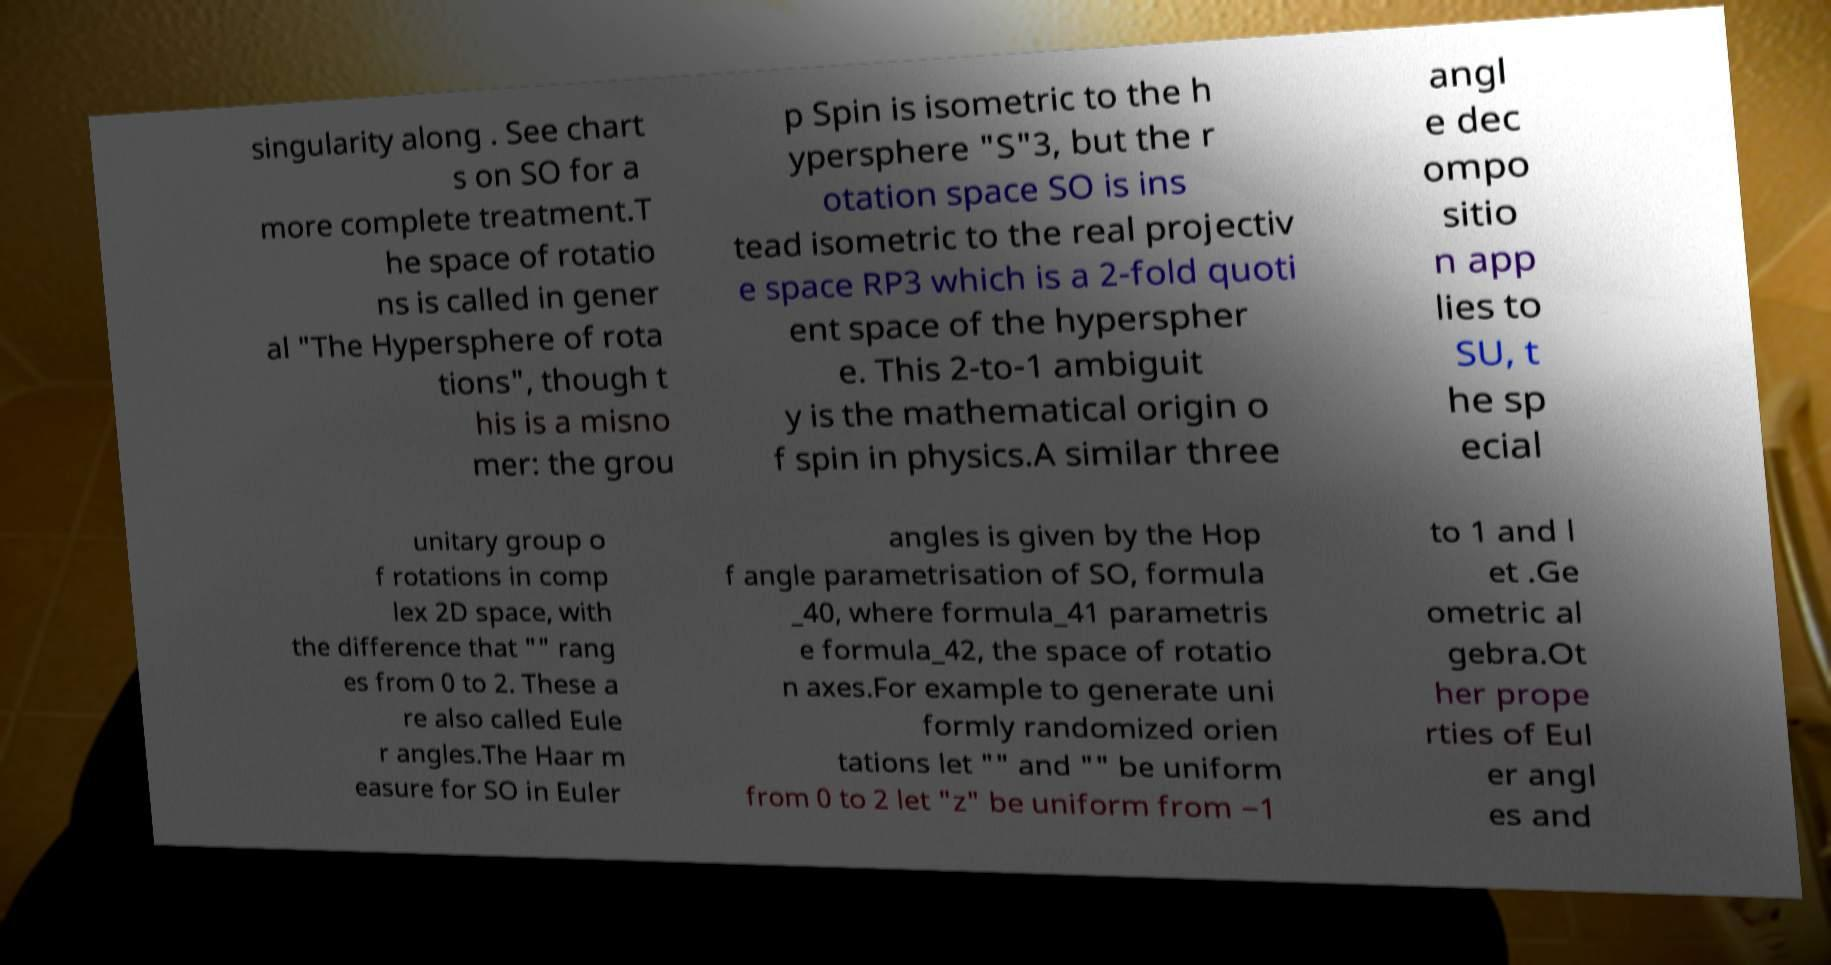Please identify and transcribe the text found in this image. singularity along . See chart s on SO for a more complete treatment.T he space of rotatio ns is called in gener al "The Hypersphere of rota tions", though t his is a misno mer: the grou p Spin is isometric to the h ypersphere "S"3, but the r otation space SO is ins tead isometric to the real projectiv e space RP3 which is a 2-fold quoti ent space of the hyperspher e. This 2-to-1 ambiguit y is the mathematical origin o f spin in physics.A similar three angl e dec ompo sitio n app lies to SU, t he sp ecial unitary group o f rotations in comp lex 2D space, with the difference that "" rang es from 0 to 2. These a re also called Eule r angles.The Haar m easure for SO in Euler angles is given by the Hop f angle parametrisation of SO, formula _40, where formula_41 parametris e formula_42, the space of rotatio n axes.For example to generate uni formly randomized orien tations let "" and "" be uniform from 0 to 2 let "z" be uniform from −1 to 1 and l et .Ge ometric al gebra.Ot her prope rties of Eul er angl es and 